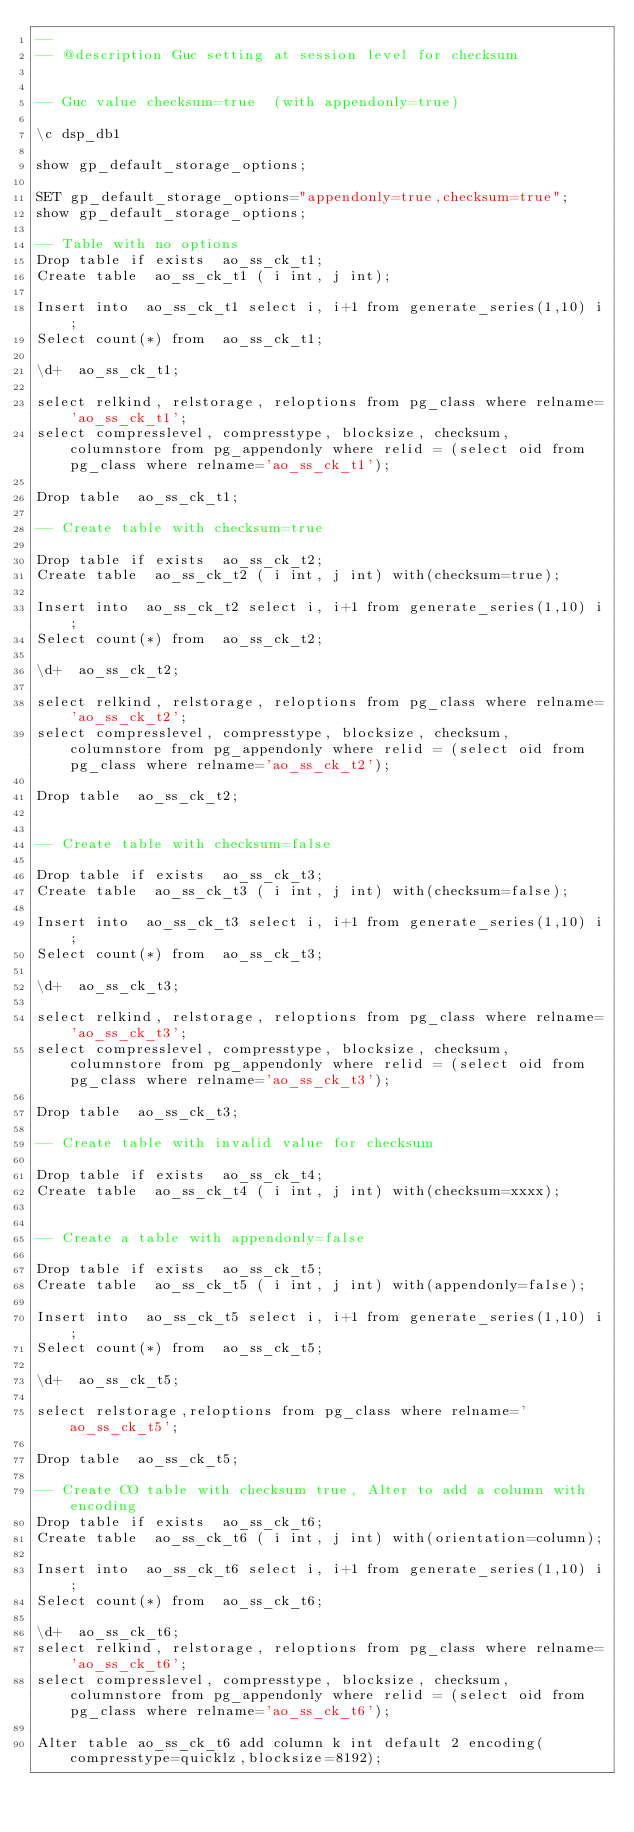Convert code to text. <code><loc_0><loc_0><loc_500><loc_500><_SQL_>-- 
-- @description Guc setting at session level for checksum


-- Guc value checksum=true  (with appendonly=true)

\c dsp_db1

show gp_default_storage_options;

SET gp_default_storage_options="appendonly=true,checksum=true";
show gp_default_storage_options;

-- Table with no options
Drop table if exists  ao_ss_ck_t1;
Create table  ao_ss_ck_t1 ( i int, j int);

Insert into  ao_ss_ck_t1 select i, i+1 from generate_series(1,10) i;
Select count(*) from  ao_ss_ck_t1;

\d+  ao_ss_ck_t1;

select relkind, relstorage, reloptions from pg_class where relname='ao_ss_ck_t1';
select compresslevel, compresstype, blocksize, checksum, columnstore from pg_appendonly where relid = (select oid from pg_class where relname='ao_ss_ck_t1');

Drop table  ao_ss_ck_t1;

-- Create table with checksum=true

Drop table if exists  ao_ss_ck_t2;
Create table  ao_ss_ck_t2 ( i int, j int) with(checksum=true);

Insert into  ao_ss_ck_t2 select i, i+1 from generate_series(1,10) i;
Select count(*) from  ao_ss_ck_t2;

\d+  ao_ss_ck_t2;

select relkind, relstorage, reloptions from pg_class where relname='ao_ss_ck_t2';
select compresslevel, compresstype, blocksize, checksum, columnstore from pg_appendonly where relid = (select oid from pg_class where relname='ao_ss_ck_t2');

Drop table  ao_ss_ck_t2;


-- Create table with checksum=false

Drop table if exists  ao_ss_ck_t3;
Create table  ao_ss_ck_t3 ( i int, j int) with(checksum=false);

Insert into  ao_ss_ck_t3 select i, i+1 from generate_series(1,10) i;
Select count(*) from  ao_ss_ck_t3;

\d+  ao_ss_ck_t3;

select relkind, relstorage, reloptions from pg_class where relname='ao_ss_ck_t3';
select compresslevel, compresstype, blocksize, checksum, columnstore from pg_appendonly where relid = (select oid from pg_class where relname='ao_ss_ck_t3');

Drop table  ao_ss_ck_t3;

-- Create table with invalid value for checksum

Drop table if exists  ao_ss_ck_t4;
Create table  ao_ss_ck_t4 ( i int, j int) with(checksum=xxxx);


-- Create a table with appendonly=false

Drop table if exists  ao_ss_ck_t5;
Create table  ao_ss_ck_t5 ( i int, j int) with(appendonly=false);

Insert into  ao_ss_ck_t5 select i, i+1 from generate_series(1,10) i;
Select count(*) from  ao_ss_ck_t5;

\d+  ao_ss_ck_t5;

select relstorage,reloptions from pg_class where relname='ao_ss_ck_t5';

Drop table  ao_ss_ck_t5;

-- Create CO table with checksum true, Alter to add a column with encoding
Drop table if exists  ao_ss_ck_t6;
Create table  ao_ss_ck_t6 ( i int, j int) with(orientation=column);

Insert into  ao_ss_ck_t6 select i, i+1 from generate_series(1,10) i;
Select count(*) from  ao_ss_ck_t6;

\d+  ao_ss_ck_t6;
select relkind, relstorage, reloptions from pg_class where relname='ao_ss_ck_t6';
select compresslevel, compresstype, blocksize, checksum, columnstore from pg_appendonly where relid = (select oid from pg_class where relname='ao_ss_ck_t6');

Alter table ao_ss_ck_t6 add column k int default 2 encoding(compresstype=quicklz,blocksize=8192);
</code> 